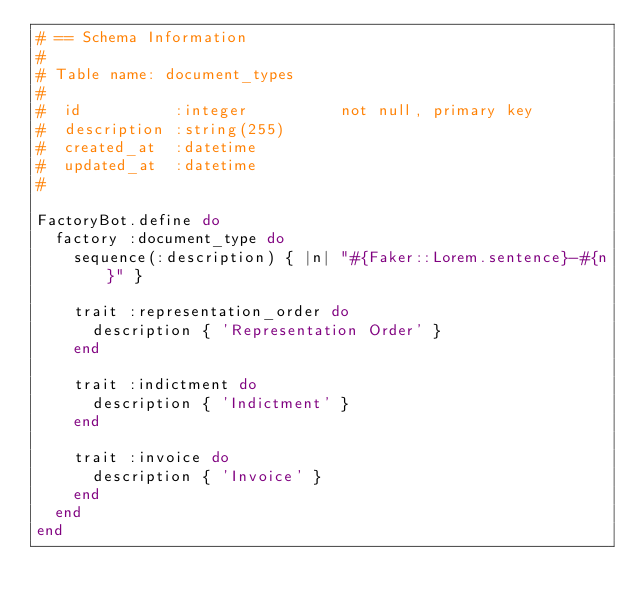<code> <loc_0><loc_0><loc_500><loc_500><_Ruby_># == Schema Information
#
# Table name: document_types
#
#  id          :integer          not null, primary key
#  description :string(255)
#  created_at  :datetime
#  updated_at  :datetime
#

FactoryBot.define do
  factory :document_type do
    sequence(:description) { |n| "#{Faker::Lorem.sentence}-#{n}" }

    trait :representation_order do
      description { 'Representation Order' }
    end

    trait :indictment do
      description { 'Indictment' }
    end

    trait :invoice do
      description { 'Invoice' }
    end
  end
end
</code> 